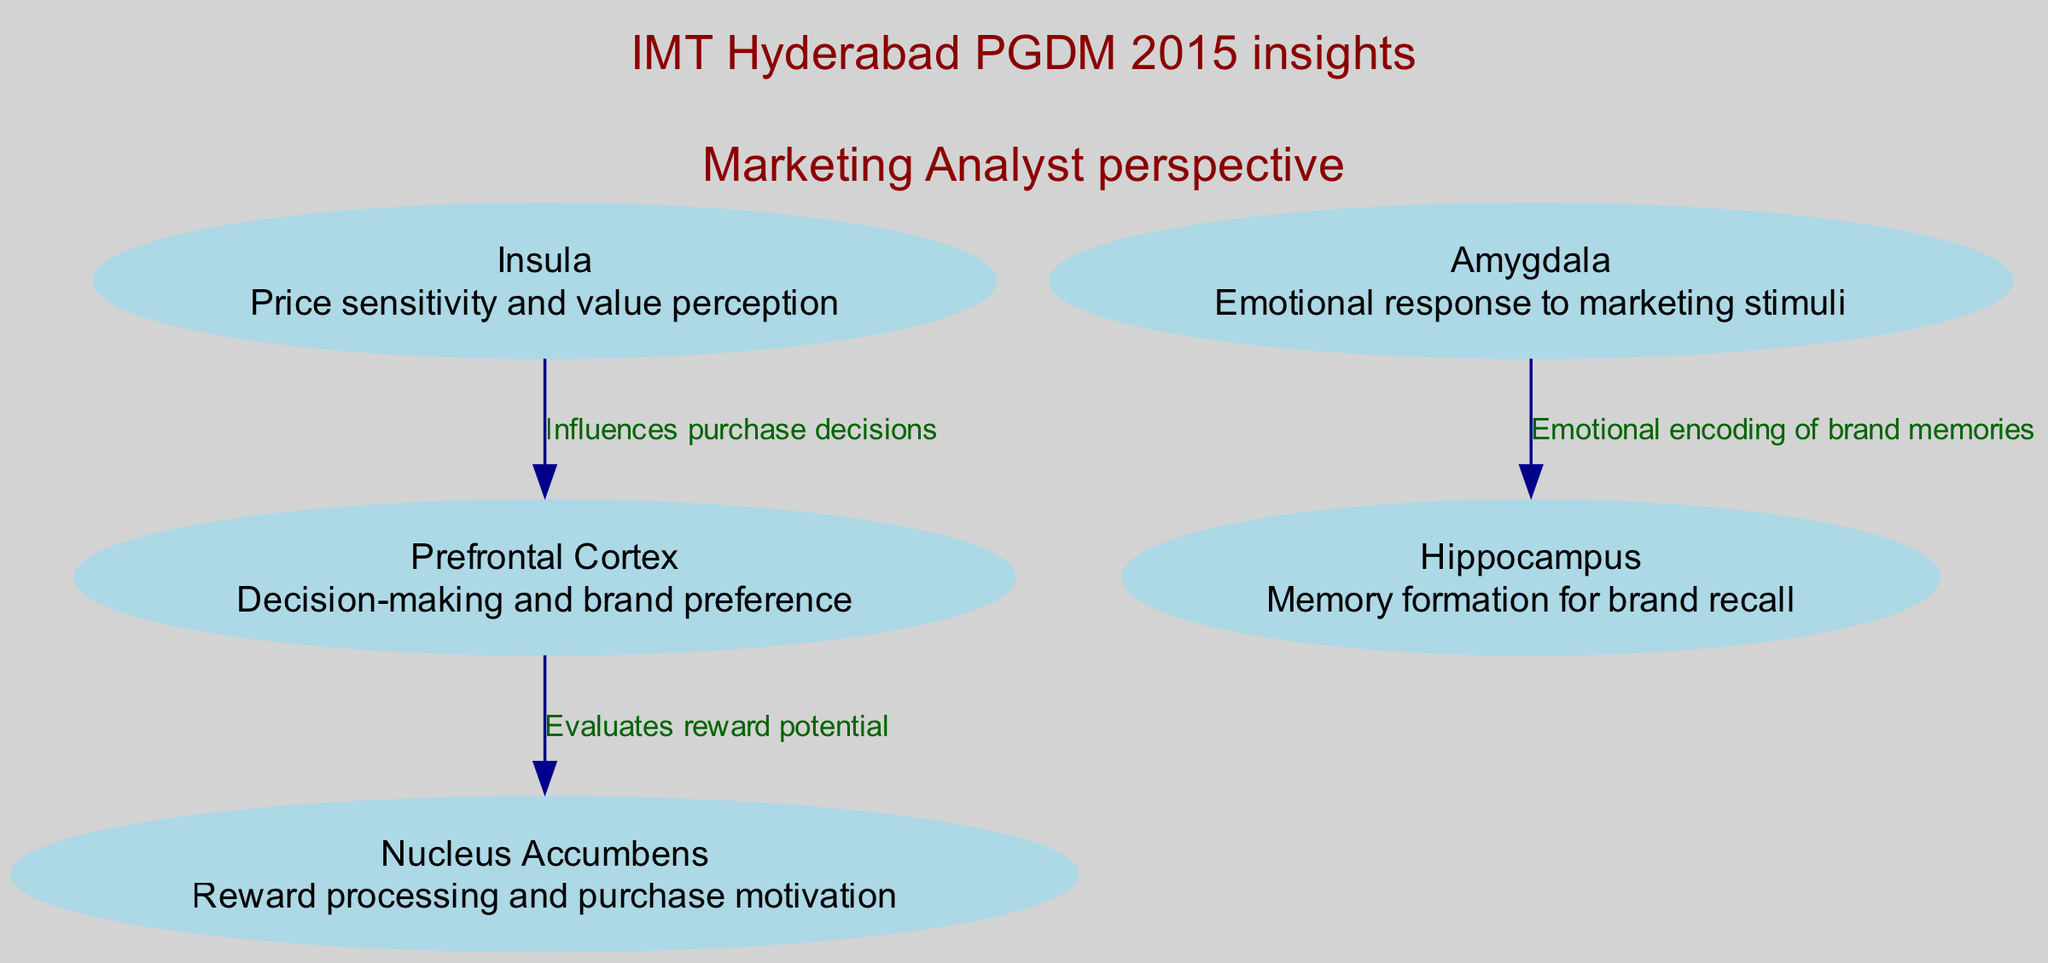What is the function of the Prefrontal Cortex? The Prefrontal Cortex is labeled in the diagram with its function, which states it is responsible for "Decision-making and brand preference."
Answer: Decision-making and brand preference How many brain regions are highlighted in the diagram? By counting the nodes representing brain regions in the diagram, there are a total of five brain regions listed.
Answer: 5 What is the connection between the Prefrontal Cortex and the Nucleus Accumbens? The diagram shows an edge labeled "Evaluates reward potential," which indicates the specific relationship between these two regions.
Answer: Evaluates reward potential What emotional role does the Amygdala play in marketing? The function of the Amygdala is noted as "Emotional response to marketing stimuli" in the diagram, which signifies its emotional role.
Answer: Emotional response to marketing stimuli Which brain region is associated with price sensitivity? The Insula is indicated in the diagram as responsible for "Price sensitivity and value perception," making it the region associated with this concept.
Answer: Insula Which brain region influences purchase decisions? The diagram reveals that the Insula also influences the Prefrontal Cortex, which in turn affects purchase decisions, indicating the Insula's influence.
Answer: Insula What is the relationship between the Amygdala and the Hippocampus? The diagram depicts an edge labeled "Emotional encoding of brand memories" connecting the Amygdala to the Hippocampus, defining their interaction.
Answer: Emotional encoding of brand memories How does the Insula affect the Prefrontal Cortex? According to the diagram, the Insula influences the Prefrontal Cortex, which indicates a directional impact on decision-making processes.
Answer: Influences purchase decisions What is the overall theme represented in the annotations of the diagram? The annotations highlight insights from "IMT Hyderabad PGDM 2015" and provide a "Marketing Analyst perspective," summarizing the focus of the diagram.
Answer: IMT Hyderabad PGDM 2015 insights, Marketing Analyst perspective 